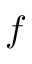<formula> <loc_0><loc_0><loc_500><loc_500>f</formula> 